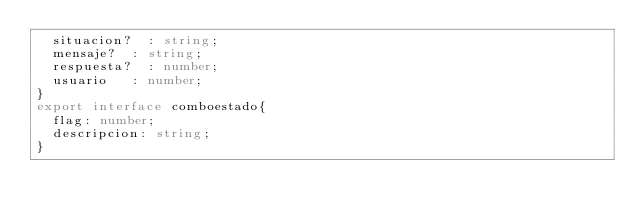<code> <loc_0><loc_0><loc_500><loc_500><_TypeScript_>	situacion?	: string;
	mensaje?	: string;
	respuesta?	: number;
	usuario		: number;
}
export interface comboestado{
	flag: number;
	descripcion: string;
}</code> 